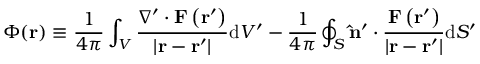Convert formula to latex. <formula><loc_0><loc_0><loc_500><loc_500>\Phi ( r ) \equiv \frac { 1 } { 4 \pi } \int _ { V } { \frac { \nabla ^ { \prime } \cdot F \left ( r ^ { \prime } \right ) } { \left | r - r ^ { \prime } \right | } } d V ^ { \prime } - { \frac { 1 } { 4 \pi } } \oint _ { S } \hat { n } ^ { \prime } \cdot { \frac { F \left ( r ^ { \prime } \right ) } { \left | r - r ^ { \prime } \right | } } d S ^ { \prime }</formula> 